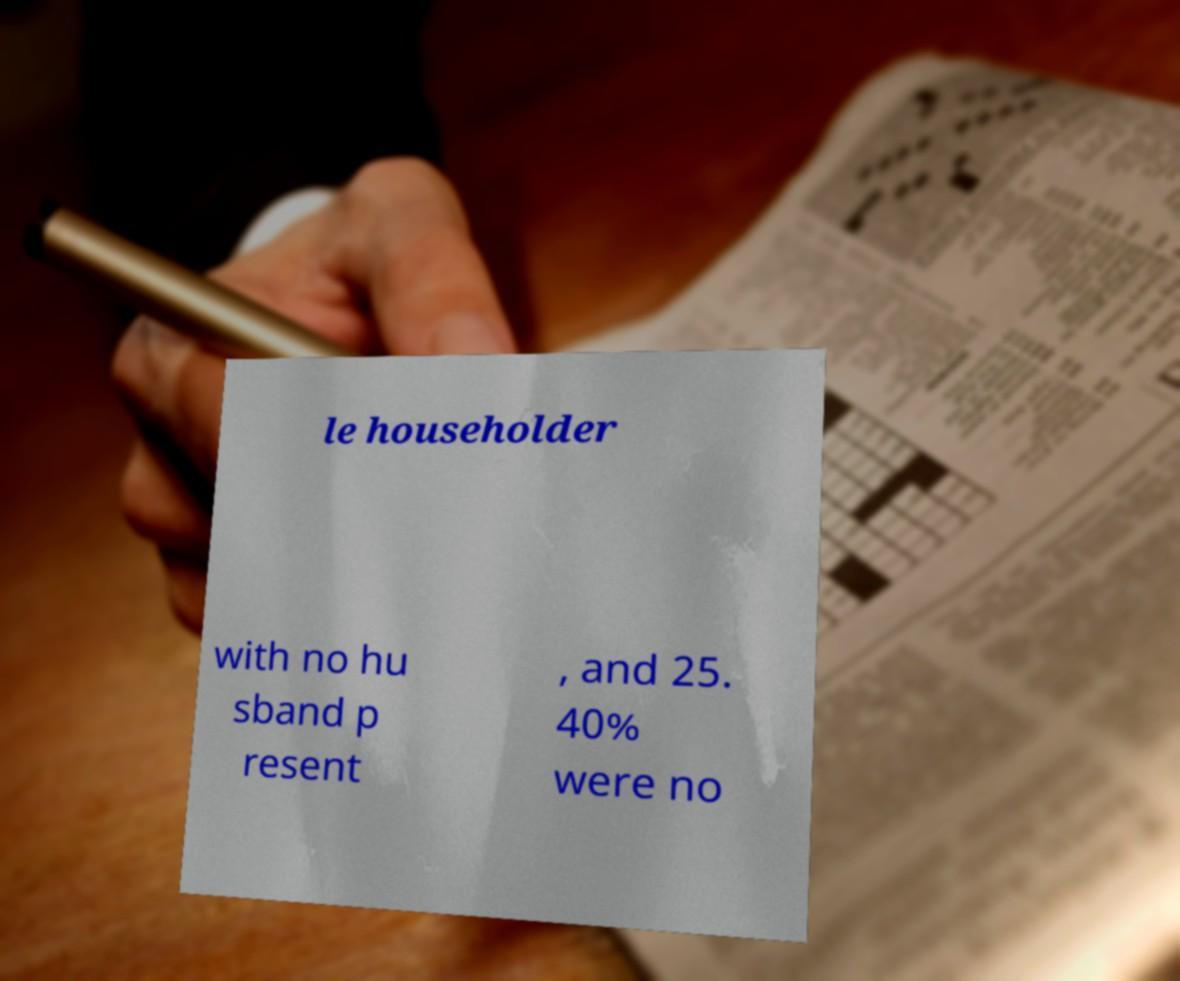Please identify and transcribe the text found in this image. le householder with no hu sband p resent , and 25. 40% were no 